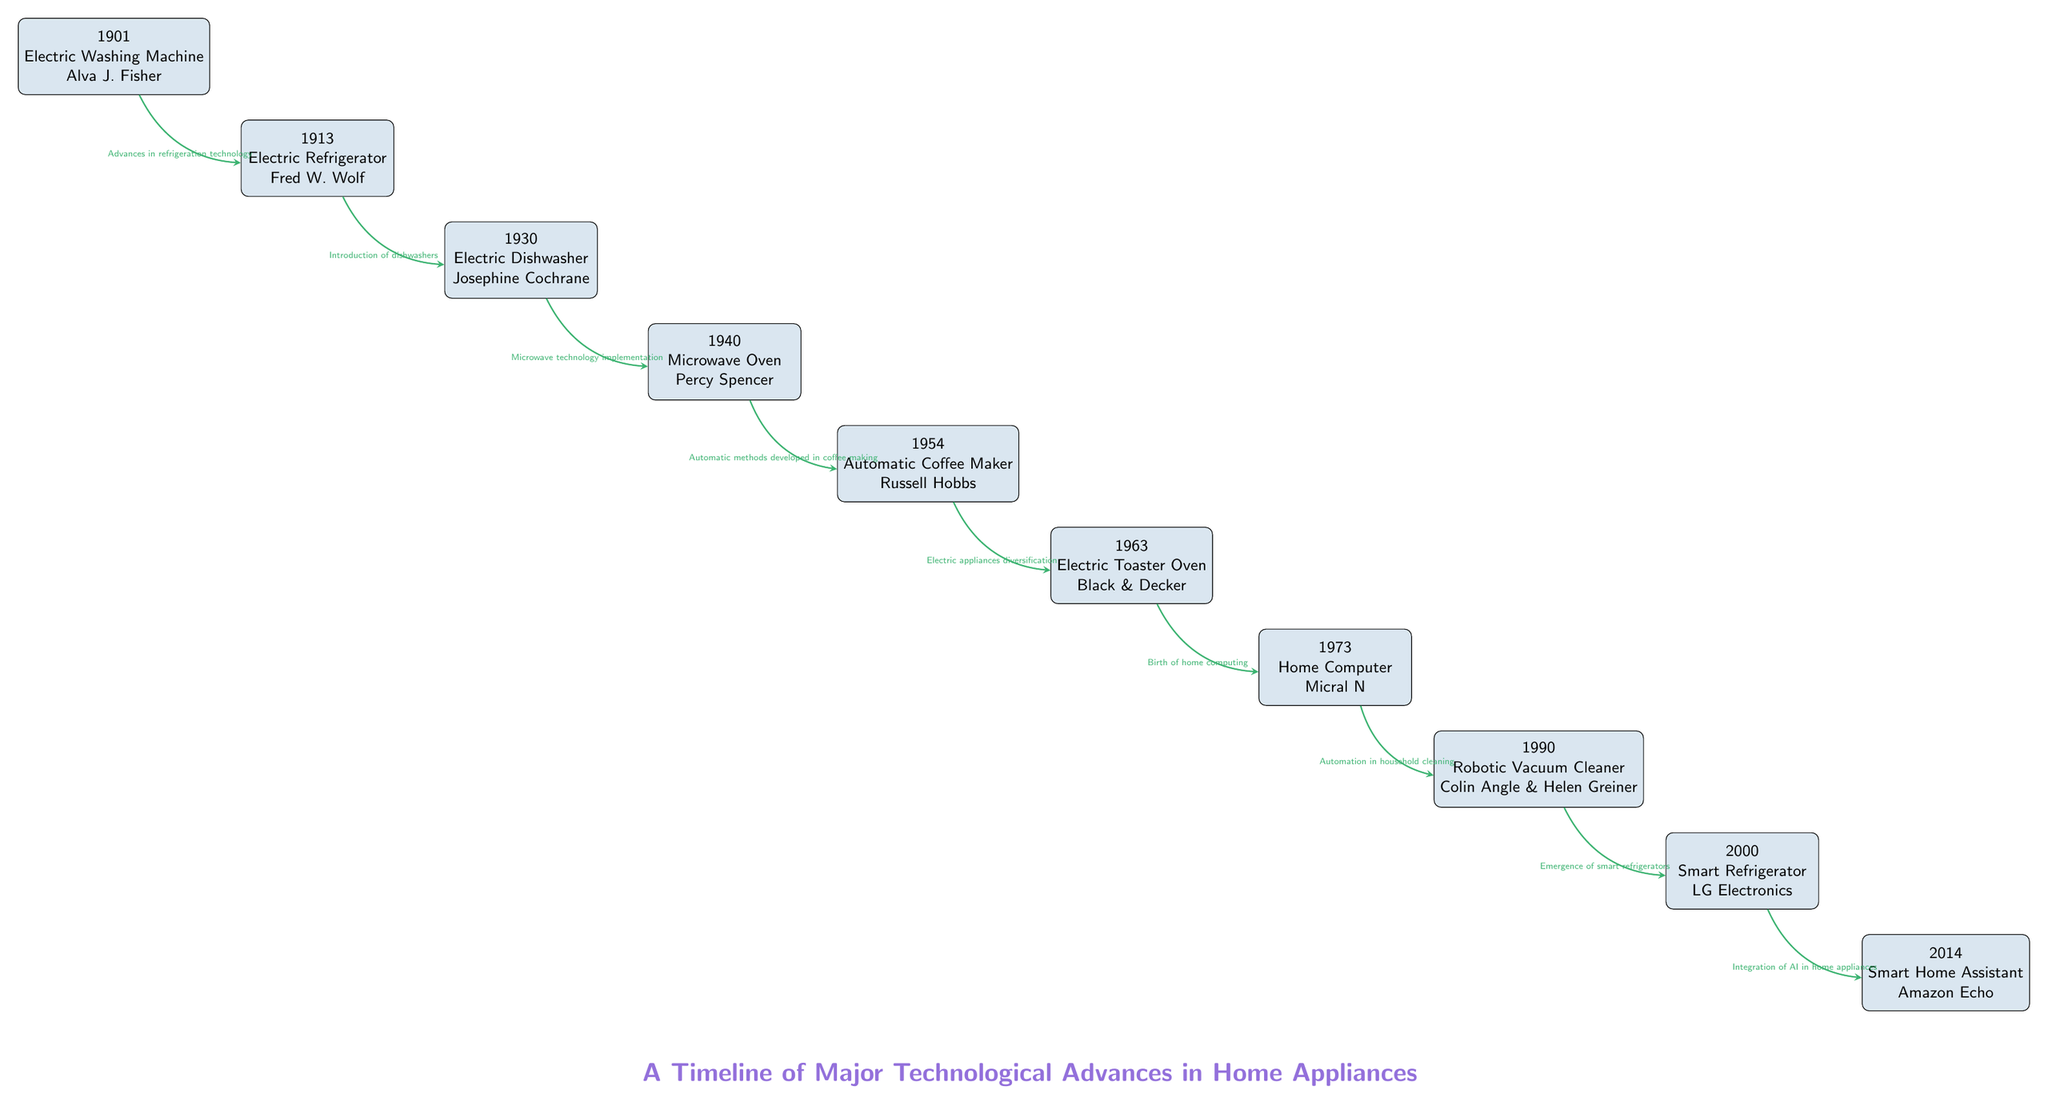What was the first technological advance in home appliances? The diagram shows that the first technological advance in home appliances is the Electric Washing Machine introduced in 1901 by Alva J. Fisher.
Answer: Electric Washing Machine Who invented the Electric Dishwasher? According to the diagram, the Electric Dishwasher was invented by Josephine Cochrane in 1930.
Answer: Josephine Cochrane Which appliance was created after the Microwave Oven? The diagram indicates that the Automatic Coffee Maker was created after the Microwave Oven, as it appears directly below it in the timeline.
Answer: Automatic Coffee Maker What year was the Smart Refrigerator introduced? By looking at the timeline, the Smart Refrigerator was introduced in the year 2000.
Answer: 2000 How many technological advances are listed in the diagram? The diagram lists a total of ten technological advances, as counted from the nodes.
Answer: 10 What development followed the introduction of the Home Computer? The diagram shows that the next development after the Home Computer was the Robotic Vacuum Cleaner, as indicated by the arrow connecting them.
Answer: Robotic Vacuum Cleaner What is the relationship between the Electric Toaster Oven and the Electric Dishwasher? The Electric Toaster Oven comes after the Electric Dishwasher in the timeline, indicating that it is a later technological advancement.
Answer: Later advancement Which appliance introduced the integration of AI? The diagram specifies that the Smart Home Assistant introduced the integration of AI in 2014.
Answer: Smart Home Assistant What is the overall theme represented in this diagram? The overall theme of the diagram is a timeline that showcases major technological advances in home appliances, connecting various inventors and technologies over the years.
Answer: Major technological advances in home appliances 